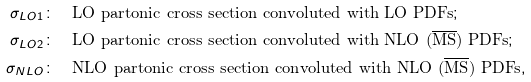Convert formula to latex. <formula><loc_0><loc_0><loc_500><loc_500>\sigma _ { L O 1 } \colon & \quad \text {LO partonic cross section convoluted with LO PDFs} ; \\ \sigma _ { L O 2 } \colon & \quad \text {LO partonic cross section convoluted with NLO   ($\overline{\text {MS}}$) PDFs} ; \\ \sigma _ { N L O } \colon & \quad \text {NLO partonic cross section convoluted with NLO   ($\overline{\text {MS}}$) PDFs} ,</formula> 